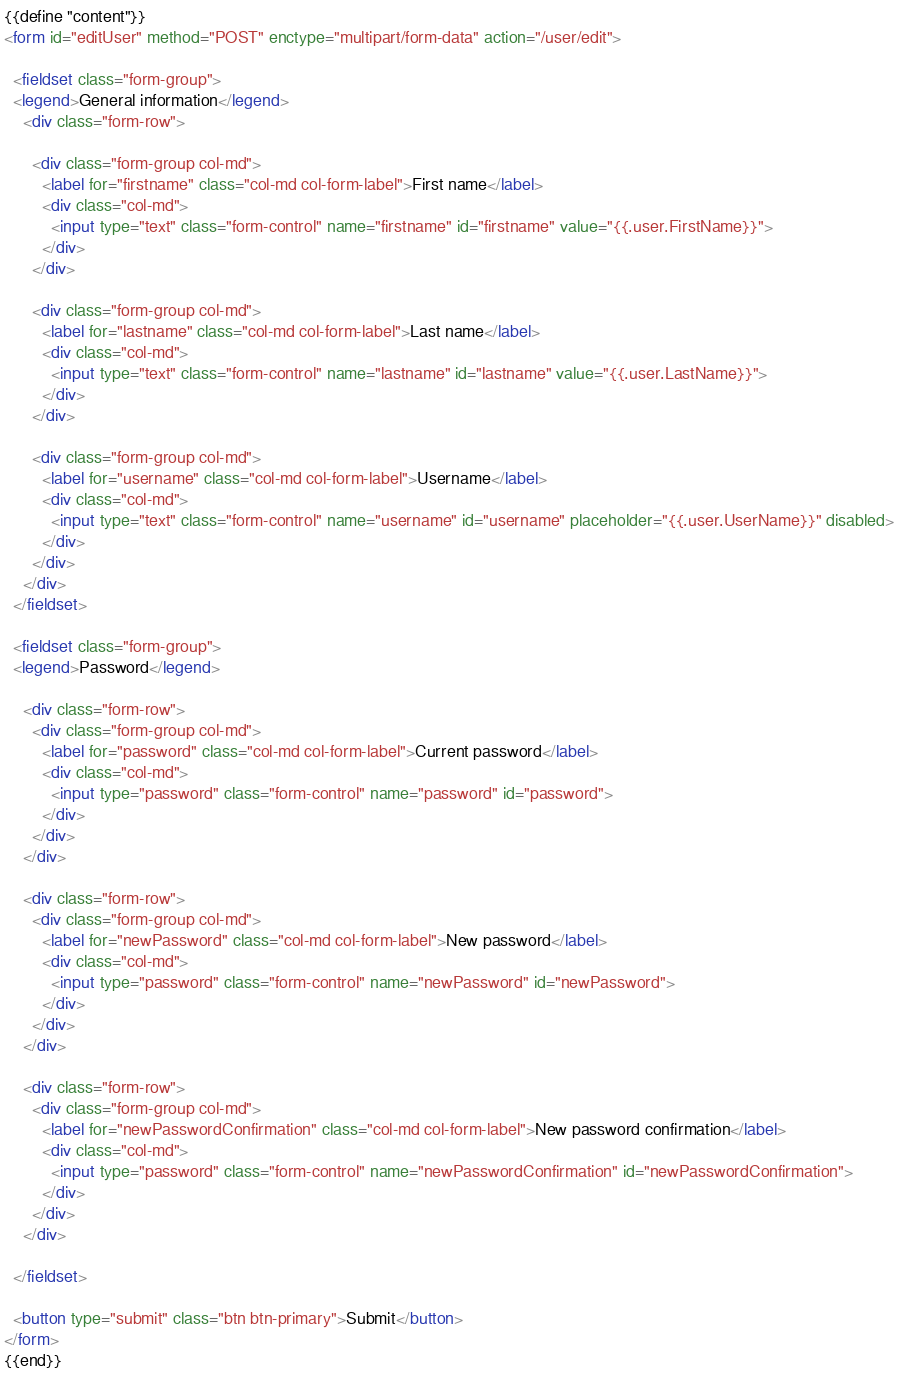Convert code to text. <code><loc_0><loc_0><loc_500><loc_500><_HTML_>{{define "content"}}
<form id="editUser" method="POST" enctype="multipart/form-data" action="/user/edit">

  <fieldset class="form-group">
  <legend>General information</legend>
    <div class="form-row">

      <div class="form-group col-md">
        <label for="firstname" class="col-md col-form-label">First name</label>
        <div class="col-md">
          <input type="text" class="form-control" name="firstname" id="firstname" value="{{.user.FirstName}}">
        </div>
      </div>

      <div class="form-group col-md">
        <label for="lastname" class="col-md col-form-label">Last name</label>
        <div class="col-md">
          <input type="text" class="form-control" name="lastname" id="lastname" value="{{.user.LastName}}">
        </div>
      </div>

      <div class="form-group col-md">
        <label for="username" class="col-md col-form-label">Username</label>
        <div class="col-md">
          <input type="text" class="form-control" name="username" id="username" placeholder="{{.user.UserName}}" disabled>
        </div>
      </div>
    </div>
  </fieldset>

  <fieldset class="form-group">
  <legend>Password</legend>

    <div class="form-row">
      <div class="form-group col-md">
        <label for="password" class="col-md col-form-label">Current password</label>
        <div class="col-md">
          <input type="password" class="form-control" name="password" id="password">
        </div>
      </div>
    </div>

    <div class="form-row">
      <div class="form-group col-md">
        <label for="newPassword" class="col-md col-form-label">New password</label>
        <div class="col-md">
          <input type="password" class="form-control" name="newPassword" id="newPassword">
        </div>
      </div>
    </div>

    <div class="form-row">
      <div class="form-group col-md">
        <label for="newPasswordConfirmation" class="col-md col-form-label">New password confirmation</label>
        <div class="col-md">
          <input type="password" class="form-control" name="newPasswordConfirmation" id="newPasswordConfirmation">
        </div>
      </div>
    </div>

  </fieldset>

  <button type="submit" class="btn btn-primary">Submit</button>
</form>
{{end}}
</code> 